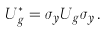Convert formula to latex. <formula><loc_0><loc_0><loc_500><loc_500>U _ { g } ^ { * } = \sigma _ { y } U _ { g } \sigma _ { y } \, .</formula> 